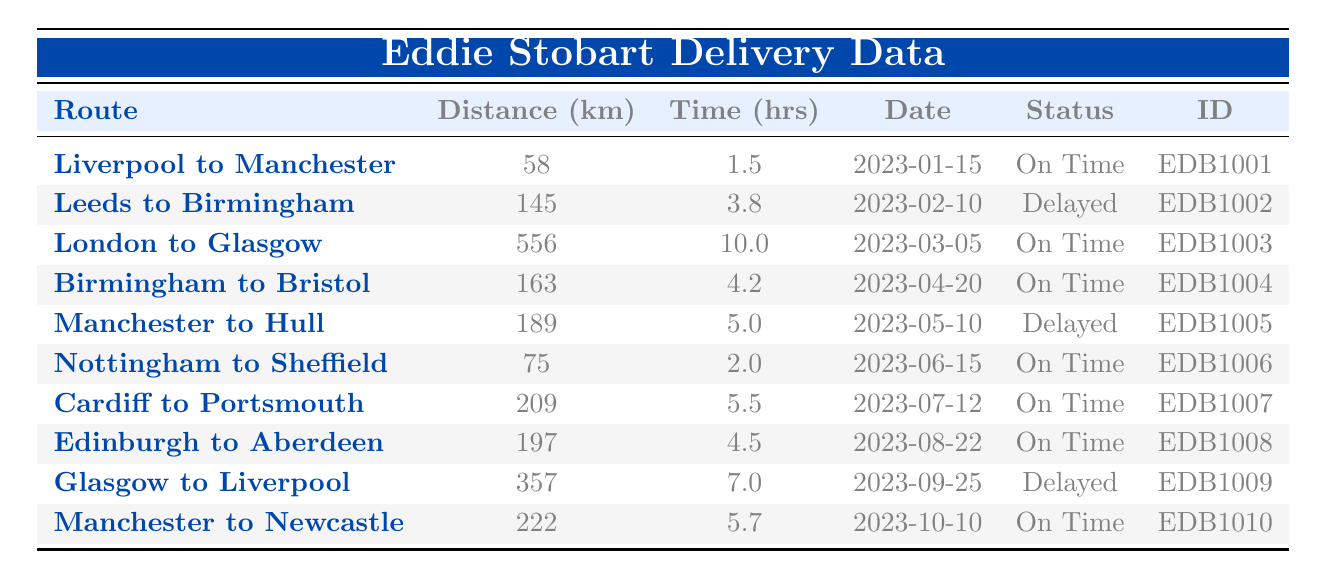What is the delivery ID for the delivery from Liverpool to Manchester? The table lists the delivery with the route "Liverpool to Manchester" and states that its delivery ID is "EDB1001."
Answer: EDB1001 How many kilometers was the delivery from Birmingham to Bristol? The table shows that the distance for the delivery from "Birmingham to Bristol" is 163 kilometers.
Answer: 163 km What was the status of the delivery from Glasgow to Liverpool? Looking at the table, the delivery status for "Glasgow to Liverpool" is marked as "Delayed."
Answer: Delayed What is the average delivery time across all routes? To find the average delivery time, add all the delivery times together: 1.5 + 3.8 + 10 + 4.2 + 5 + 2 + 5.5 + 4.5 + 7 + 5.7 = 50.2 hours. Then divide by the number of deliveries (10): 50.2 / 10 = 5.02 hours.
Answer: 5.02 hours What is the longest delivery time in hours? By examining the delivery times in the table, the longest delivery time is 10 hours for the route "London to Glasgow."
Answer: 10 hours How many deliveries were delayed? By counting the statuses in the table, there are two deliveries marked as "Delayed" (EDB1002 and EDB1005).
Answer: 2 Which route had the shortest distance? The shortest distance is for the route "Liverpool to Manchester," which is 58 kilometers, the value listed in the distance column.
Answer: Liverpool to Manchester Is the delivery from Cardiff to Portsmouth on time? The status for the "Cardiff to Portsmouth" delivery entry in the table shows "On Time."
Answer: Yes What is the total distance covered by all deliveries? To find the total distance, add all the distances: 58 + 145 + 556 + 163 + 189 + 75 + 209 + 197 + 357 + 222 = 2071 kilometers.
Answer: 2071 km Was there a delivery from Leeds to Birmingham on time? The table indicates that the delivery from "Leeds to Birmingham" is marked as "Delayed."
Answer: No 